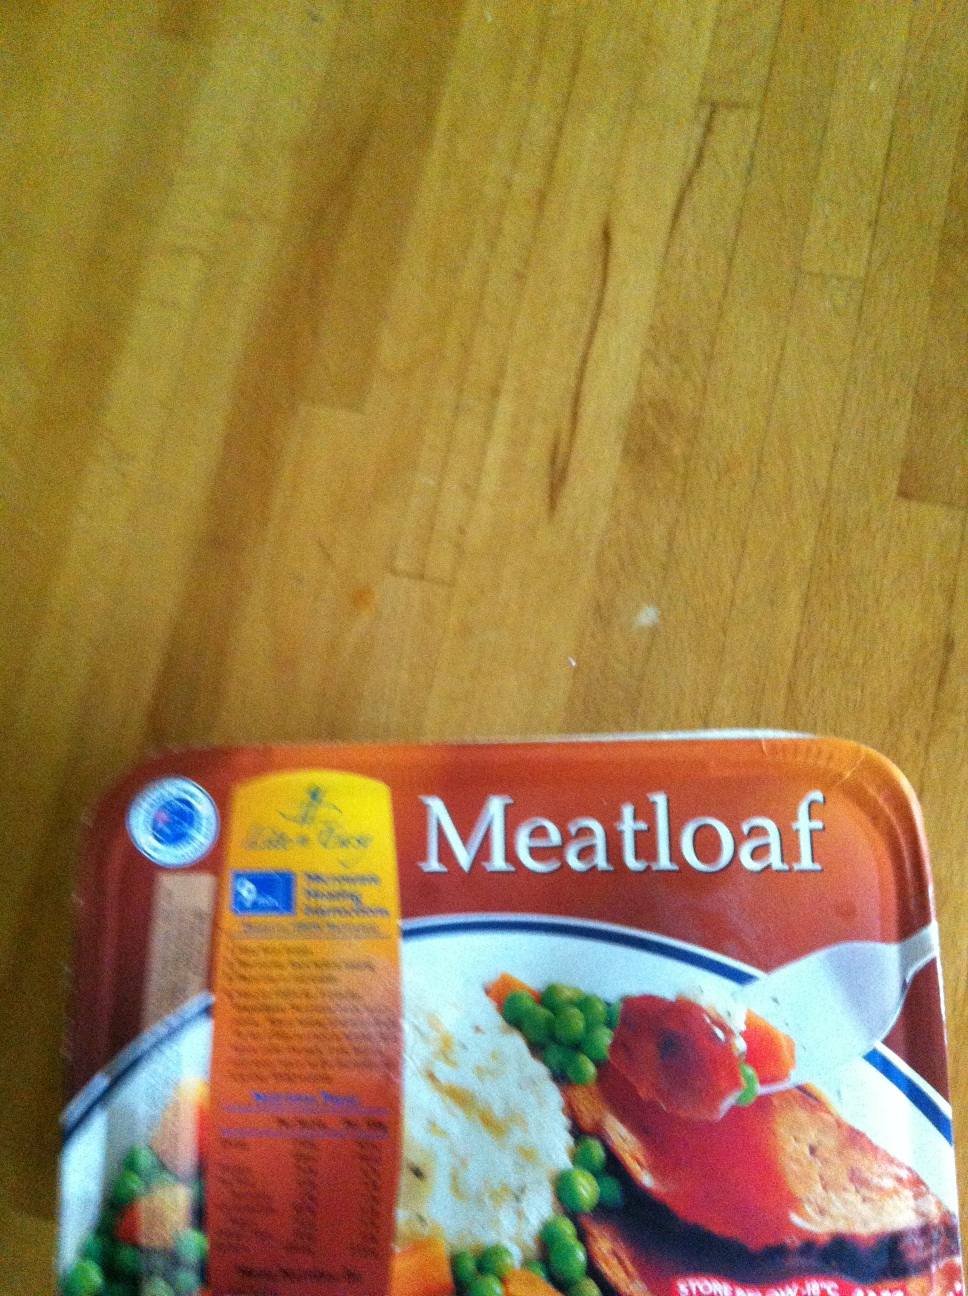If you could taste this meatloaf, what flavors would you expect? I would expect the meatloaf to have a rich and savory flavor, with a perfect balance of spices. The taste of the tender, juicy meat would blend harmoniously with the subtle sweetness from the onions and the aromatic warmth of garlic. There might be a slight tang from ketchup or tomato glaze baked on top, adding a delightful contrast. The accompanying vegetables would provide a fresh, slightly sweet taste to balance the meatloaf's hearty flavor. 